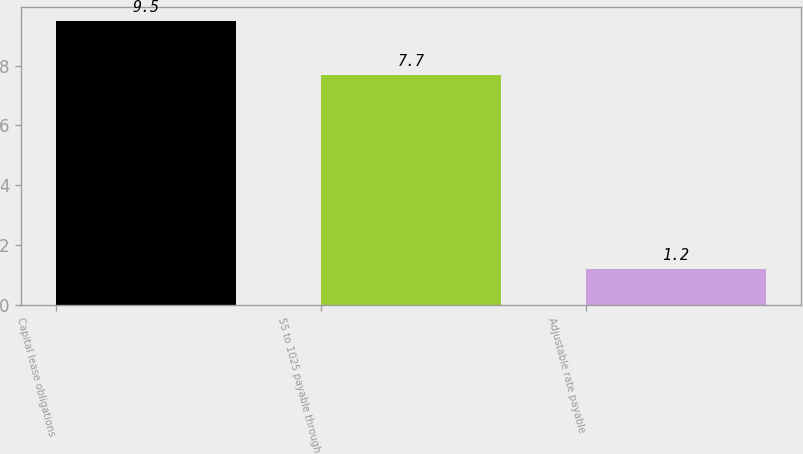Convert chart. <chart><loc_0><loc_0><loc_500><loc_500><bar_chart><fcel>Capital lease obligations<fcel>55 to 1025 payable through<fcel>Adjustable rate payable<nl><fcel>9.5<fcel>7.7<fcel>1.2<nl></chart> 